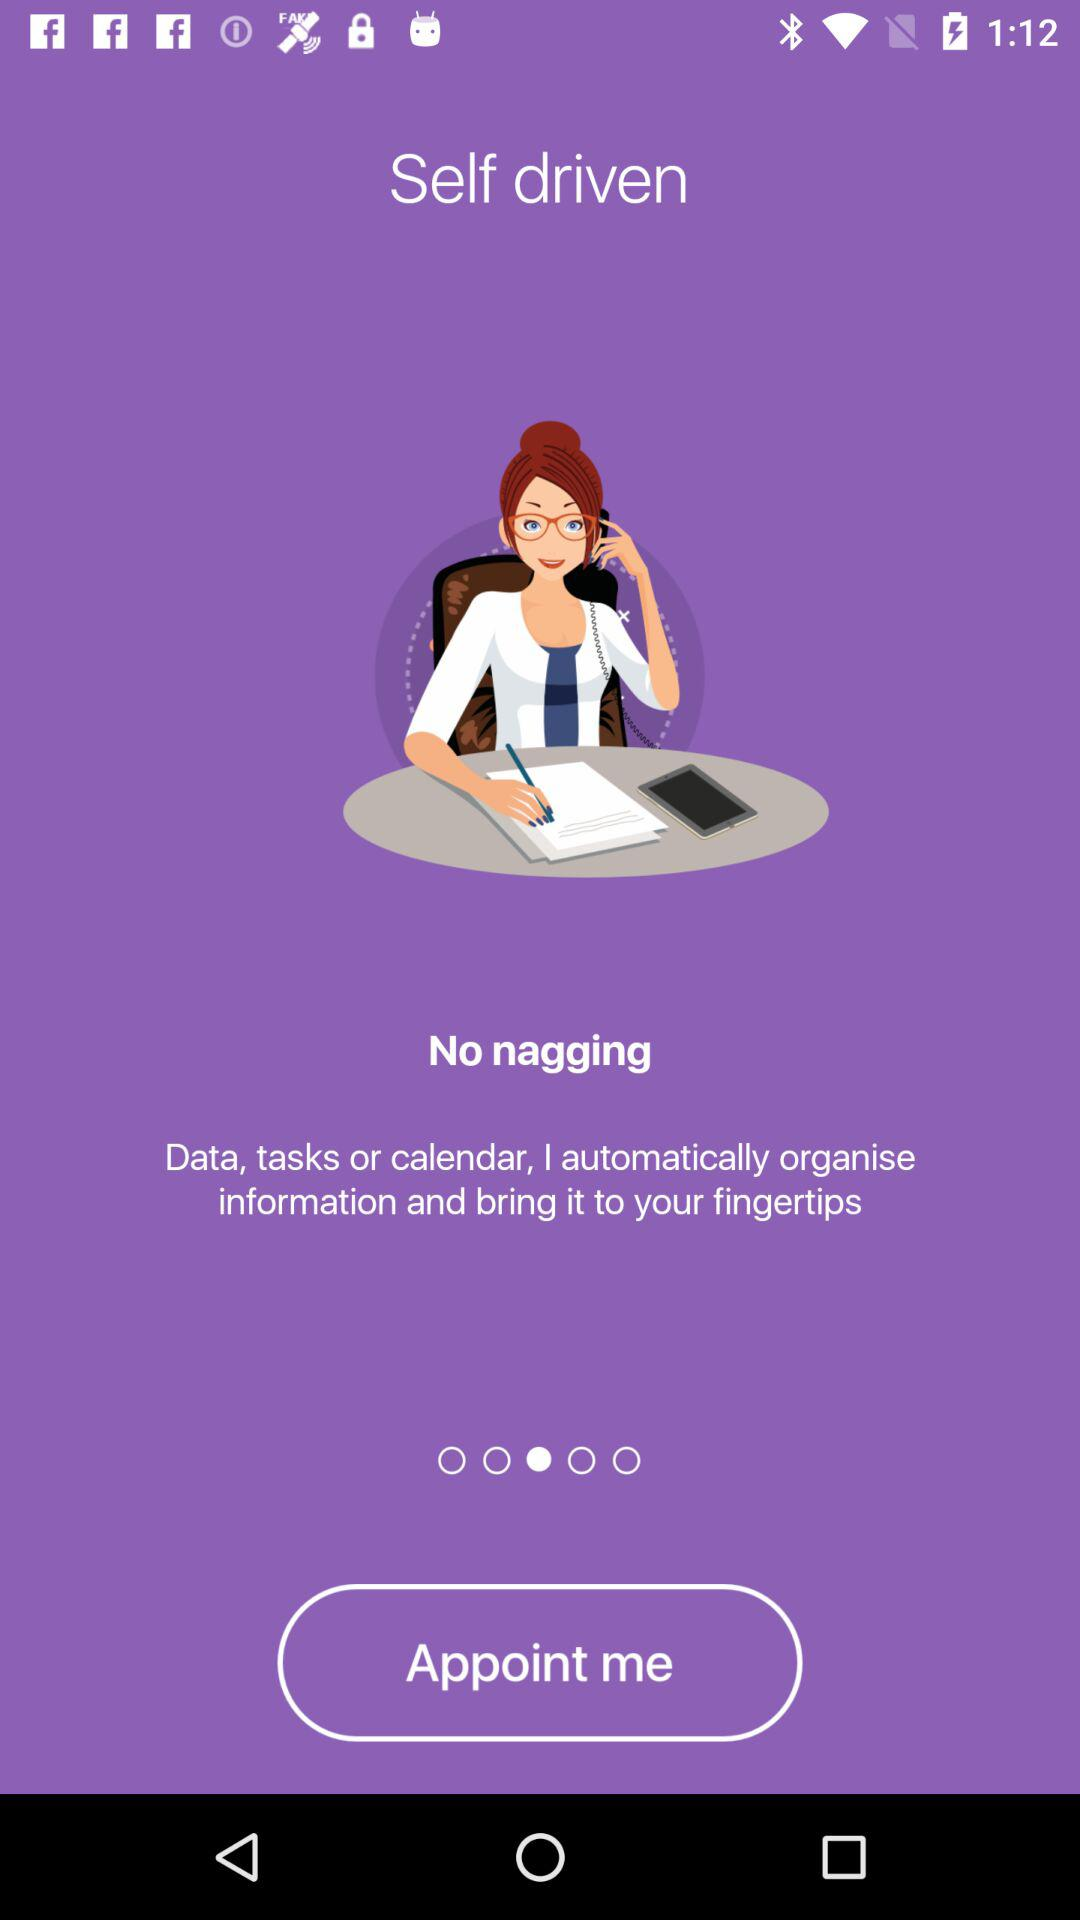What is the application name?
When the provided information is insufficient, respond with <no answer>. <no answer> 